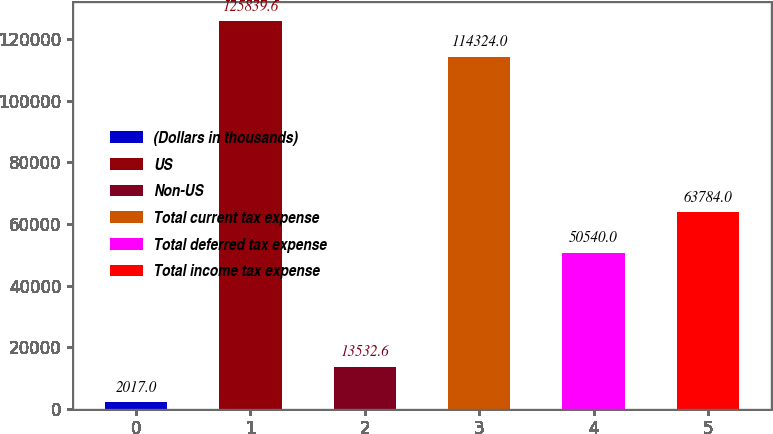Convert chart. <chart><loc_0><loc_0><loc_500><loc_500><bar_chart><fcel>(Dollars in thousands)<fcel>US<fcel>Non-US<fcel>Total current tax expense<fcel>Total deferred tax expense<fcel>Total income tax expense<nl><fcel>2017<fcel>125840<fcel>13532.6<fcel>114324<fcel>50540<fcel>63784<nl></chart> 